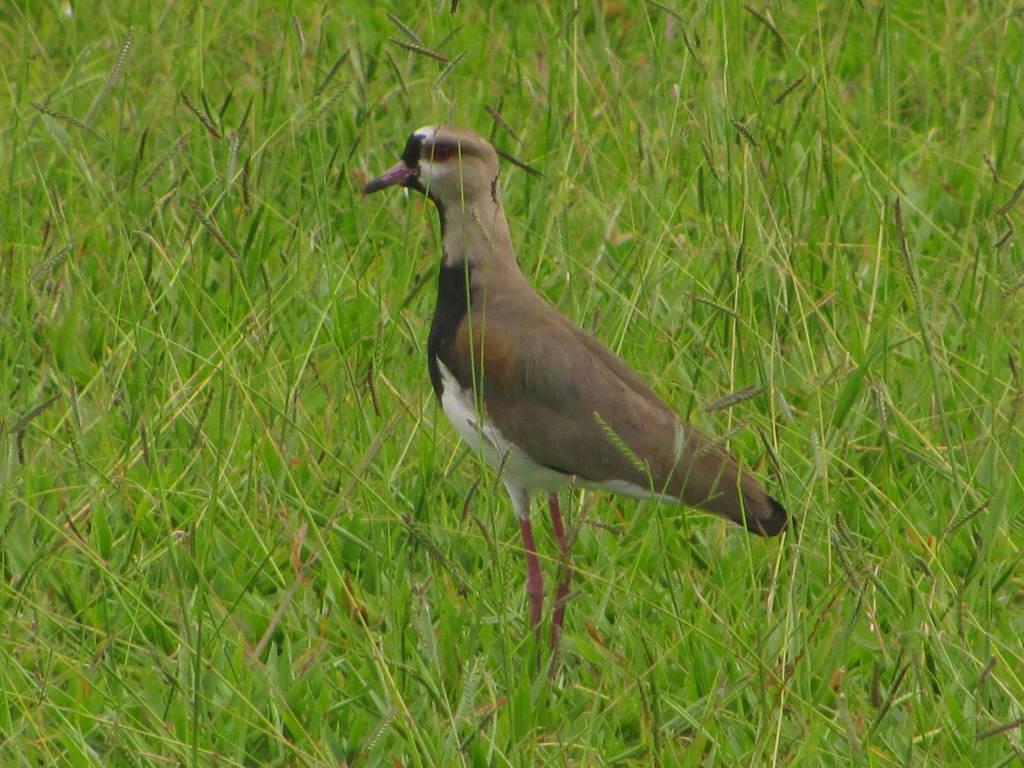What type of bird is in the image? There is a killdeer bird in the image. What is the bird standing on in the image? The bird is standing on the grass. How does the bird show respect to the other birds in the image? There is no indication in the image that the bird is showing respect to other birds, as there are no other birds present. Can you tell me if the bird is currently in flight in the image? The image only shows the bird standing on the grass, so it cannot be determined if the bird is in flight. 